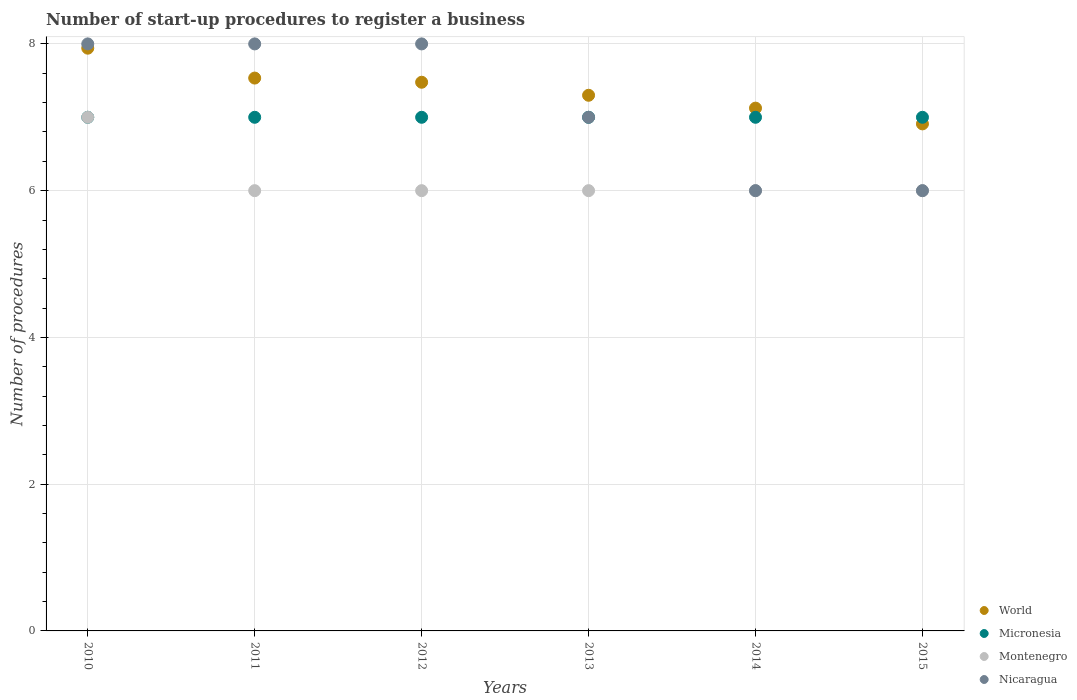How many different coloured dotlines are there?
Make the answer very short. 4. Is the number of dotlines equal to the number of legend labels?
Your response must be concise. Yes. What is the number of procedures required to register a business in Montenegro in 2012?
Offer a very short reply. 6. Across all years, what is the maximum number of procedures required to register a business in Montenegro?
Offer a very short reply. 7. Across all years, what is the minimum number of procedures required to register a business in Micronesia?
Ensure brevity in your answer.  7. In which year was the number of procedures required to register a business in World maximum?
Your answer should be very brief. 2010. In which year was the number of procedures required to register a business in Montenegro minimum?
Your response must be concise. 2011. What is the total number of procedures required to register a business in Micronesia in the graph?
Offer a very short reply. 42. What is the difference between the number of procedures required to register a business in World in 2014 and that in 2015?
Your answer should be very brief. 0.21. What is the difference between the number of procedures required to register a business in Nicaragua in 2014 and the number of procedures required to register a business in Micronesia in 2012?
Provide a short and direct response. -1. What is the average number of procedures required to register a business in World per year?
Your answer should be compact. 7.38. In the year 2014, what is the difference between the number of procedures required to register a business in Montenegro and number of procedures required to register a business in Micronesia?
Your answer should be compact. -1. What is the ratio of the number of procedures required to register a business in Nicaragua in 2011 to that in 2012?
Give a very brief answer. 1. Is the number of procedures required to register a business in World in 2014 less than that in 2015?
Offer a terse response. No. What is the difference between the highest and the lowest number of procedures required to register a business in Nicaragua?
Provide a succinct answer. 2. Is it the case that in every year, the sum of the number of procedures required to register a business in Montenegro and number of procedures required to register a business in World  is greater than the sum of number of procedures required to register a business in Micronesia and number of procedures required to register a business in Nicaragua?
Provide a succinct answer. No. Is the number of procedures required to register a business in Micronesia strictly greater than the number of procedures required to register a business in Montenegro over the years?
Ensure brevity in your answer.  No. How many dotlines are there?
Provide a short and direct response. 4. How many legend labels are there?
Offer a very short reply. 4. What is the title of the graph?
Offer a very short reply. Number of start-up procedures to register a business. What is the label or title of the X-axis?
Your response must be concise. Years. What is the label or title of the Y-axis?
Your response must be concise. Number of procedures. What is the Number of procedures in World in 2010?
Offer a terse response. 7.94. What is the Number of procedures of Micronesia in 2010?
Ensure brevity in your answer.  7. What is the Number of procedures of Montenegro in 2010?
Offer a very short reply. 7. What is the Number of procedures in World in 2011?
Provide a short and direct response. 7.53. What is the Number of procedures of Micronesia in 2011?
Offer a terse response. 7. What is the Number of procedures of Montenegro in 2011?
Give a very brief answer. 6. What is the Number of procedures in World in 2012?
Offer a terse response. 7.48. What is the Number of procedures in Micronesia in 2012?
Offer a very short reply. 7. What is the Number of procedures of World in 2013?
Offer a terse response. 7.3. What is the Number of procedures of Micronesia in 2013?
Provide a succinct answer. 7. What is the Number of procedures in Montenegro in 2013?
Provide a succinct answer. 6. What is the Number of procedures of Nicaragua in 2013?
Make the answer very short. 7. What is the Number of procedures of World in 2014?
Provide a succinct answer. 7.12. What is the Number of procedures in Micronesia in 2014?
Your answer should be compact. 7. What is the Number of procedures in Montenegro in 2014?
Offer a terse response. 6. What is the Number of procedures of Nicaragua in 2014?
Your response must be concise. 6. What is the Number of procedures of World in 2015?
Offer a very short reply. 6.91. What is the Number of procedures in Montenegro in 2015?
Your answer should be compact. 6. Across all years, what is the maximum Number of procedures of World?
Offer a terse response. 7.94. Across all years, what is the maximum Number of procedures in Micronesia?
Ensure brevity in your answer.  7. Across all years, what is the maximum Number of procedures in Montenegro?
Keep it short and to the point. 7. Across all years, what is the minimum Number of procedures in World?
Your answer should be compact. 6.91. What is the total Number of procedures in World in the graph?
Make the answer very short. 44.29. What is the total Number of procedures of Micronesia in the graph?
Make the answer very short. 42. What is the total Number of procedures of Nicaragua in the graph?
Offer a terse response. 43. What is the difference between the Number of procedures in World in 2010 and that in 2011?
Make the answer very short. 0.41. What is the difference between the Number of procedures of World in 2010 and that in 2012?
Offer a terse response. 0.46. What is the difference between the Number of procedures in Micronesia in 2010 and that in 2012?
Ensure brevity in your answer.  0. What is the difference between the Number of procedures in Nicaragua in 2010 and that in 2012?
Offer a very short reply. 0. What is the difference between the Number of procedures of World in 2010 and that in 2013?
Give a very brief answer. 0.64. What is the difference between the Number of procedures of World in 2010 and that in 2014?
Keep it short and to the point. 0.82. What is the difference between the Number of procedures of Montenegro in 2010 and that in 2014?
Your answer should be compact. 1. What is the difference between the Number of procedures of Nicaragua in 2010 and that in 2014?
Offer a terse response. 2. What is the difference between the Number of procedures of World in 2010 and that in 2015?
Your answer should be compact. 1.03. What is the difference between the Number of procedures in World in 2011 and that in 2012?
Provide a short and direct response. 0.06. What is the difference between the Number of procedures of Micronesia in 2011 and that in 2012?
Offer a terse response. 0. What is the difference between the Number of procedures of Montenegro in 2011 and that in 2012?
Give a very brief answer. 0. What is the difference between the Number of procedures of World in 2011 and that in 2013?
Your answer should be very brief. 0.23. What is the difference between the Number of procedures in Nicaragua in 2011 and that in 2013?
Provide a short and direct response. 1. What is the difference between the Number of procedures of World in 2011 and that in 2014?
Offer a terse response. 0.41. What is the difference between the Number of procedures of Micronesia in 2011 and that in 2014?
Your answer should be compact. 0. What is the difference between the Number of procedures of Montenegro in 2011 and that in 2014?
Provide a succinct answer. 0. What is the difference between the Number of procedures of Nicaragua in 2011 and that in 2014?
Keep it short and to the point. 2. What is the difference between the Number of procedures in World in 2011 and that in 2015?
Make the answer very short. 0.62. What is the difference between the Number of procedures in Micronesia in 2011 and that in 2015?
Provide a succinct answer. 0. What is the difference between the Number of procedures in Nicaragua in 2011 and that in 2015?
Offer a very short reply. 2. What is the difference between the Number of procedures in World in 2012 and that in 2013?
Provide a succinct answer. 0.18. What is the difference between the Number of procedures in Micronesia in 2012 and that in 2013?
Provide a short and direct response. 0. What is the difference between the Number of procedures of Montenegro in 2012 and that in 2013?
Make the answer very short. 0. What is the difference between the Number of procedures in World in 2012 and that in 2014?
Ensure brevity in your answer.  0.35. What is the difference between the Number of procedures in Nicaragua in 2012 and that in 2014?
Give a very brief answer. 2. What is the difference between the Number of procedures in World in 2012 and that in 2015?
Provide a short and direct response. 0.57. What is the difference between the Number of procedures of World in 2013 and that in 2014?
Provide a succinct answer. 0.18. What is the difference between the Number of procedures in Micronesia in 2013 and that in 2014?
Your response must be concise. 0. What is the difference between the Number of procedures in Nicaragua in 2013 and that in 2014?
Provide a succinct answer. 1. What is the difference between the Number of procedures in World in 2013 and that in 2015?
Make the answer very short. 0.39. What is the difference between the Number of procedures of Nicaragua in 2013 and that in 2015?
Give a very brief answer. 1. What is the difference between the Number of procedures of World in 2014 and that in 2015?
Keep it short and to the point. 0.21. What is the difference between the Number of procedures in Micronesia in 2014 and that in 2015?
Provide a succinct answer. 0. What is the difference between the Number of procedures in Montenegro in 2014 and that in 2015?
Your response must be concise. 0. What is the difference between the Number of procedures in Nicaragua in 2014 and that in 2015?
Offer a terse response. 0. What is the difference between the Number of procedures in World in 2010 and the Number of procedures in Micronesia in 2011?
Ensure brevity in your answer.  0.94. What is the difference between the Number of procedures of World in 2010 and the Number of procedures of Montenegro in 2011?
Ensure brevity in your answer.  1.94. What is the difference between the Number of procedures in World in 2010 and the Number of procedures in Nicaragua in 2011?
Your answer should be compact. -0.06. What is the difference between the Number of procedures in Montenegro in 2010 and the Number of procedures in Nicaragua in 2011?
Give a very brief answer. -1. What is the difference between the Number of procedures in World in 2010 and the Number of procedures in Micronesia in 2012?
Your answer should be very brief. 0.94. What is the difference between the Number of procedures in World in 2010 and the Number of procedures in Montenegro in 2012?
Provide a succinct answer. 1.94. What is the difference between the Number of procedures of World in 2010 and the Number of procedures of Nicaragua in 2012?
Provide a short and direct response. -0.06. What is the difference between the Number of procedures in Micronesia in 2010 and the Number of procedures in Nicaragua in 2012?
Your answer should be compact. -1. What is the difference between the Number of procedures in World in 2010 and the Number of procedures in Micronesia in 2013?
Your response must be concise. 0.94. What is the difference between the Number of procedures in World in 2010 and the Number of procedures in Montenegro in 2013?
Provide a short and direct response. 1.94. What is the difference between the Number of procedures in World in 2010 and the Number of procedures in Nicaragua in 2013?
Provide a short and direct response. 0.94. What is the difference between the Number of procedures in World in 2010 and the Number of procedures in Micronesia in 2014?
Make the answer very short. 0.94. What is the difference between the Number of procedures in World in 2010 and the Number of procedures in Montenegro in 2014?
Provide a short and direct response. 1.94. What is the difference between the Number of procedures of World in 2010 and the Number of procedures of Nicaragua in 2014?
Offer a terse response. 1.94. What is the difference between the Number of procedures in Micronesia in 2010 and the Number of procedures in Montenegro in 2014?
Offer a terse response. 1. What is the difference between the Number of procedures in World in 2010 and the Number of procedures in Micronesia in 2015?
Your answer should be very brief. 0.94. What is the difference between the Number of procedures of World in 2010 and the Number of procedures of Montenegro in 2015?
Provide a short and direct response. 1.94. What is the difference between the Number of procedures of World in 2010 and the Number of procedures of Nicaragua in 2015?
Keep it short and to the point. 1.94. What is the difference between the Number of procedures in Micronesia in 2010 and the Number of procedures in Nicaragua in 2015?
Your answer should be compact. 1. What is the difference between the Number of procedures of World in 2011 and the Number of procedures of Micronesia in 2012?
Your response must be concise. 0.53. What is the difference between the Number of procedures in World in 2011 and the Number of procedures in Montenegro in 2012?
Keep it short and to the point. 1.53. What is the difference between the Number of procedures in World in 2011 and the Number of procedures in Nicaragua in 2012?
Ensure brevity in your answer.  -0.47. What is the difference between the Number of procedures of Micronesia in 2011 and the Number of procedures of Nicaragua in 2012?
Provide a short and direct response. -1. What is the difference between the Number of procedures in Montenegro in 2011 and the Number of procedures in Nicaragua in 2012?
Offer a very short reply. -2. What is the difference between the Number of procedures of World in 2011 and the Number of procedures of Micronesia in 2013?
Offer a terse response. 0.53. What is the difference between the Number of procedures in World in 2011 and the Number of procedures in Montenegro in 2013?
Offer a terse response. 1.53. What is the difference between the Number of procedures in World in 2011 and the Number of procedures in Nicaragua in 2013?
Give a very brief answer. 0.53. What is the difference between the Number of procedures of Micronesia in 2011 and the Number of procedures of Nicaragua in 2013?
Offer a very short reply. 0. What is the difference between the Number of procedures of World in 2011 and the Number of procedures of Micronesia in 2014?
Offer a terse response. 0.53. What is the difference between the Number of procedures in World in 2011 and the Number of procedures in Montenegro in 2014?
Keep it short and to the point. 1.53. What is the difference between the Number of procedures in World in 2011 and the Number of procedures in Nicaragua in 2014?
Keep it short and to the point. 1.53. What is the difference between the Number of procedures in Micronesia in 2011 and the Number of procedures in Nicaragua in 2014?
Give a very brief answer. 1. What is the difference between the Number of procedures in Montenegro in 2011 and the Number of procedures in Nicaragua in 2014?
Your response must be concise. 0. What is the difference between the Number of procedures of World in 2011 and the Number of procedures of Micronesia in 2015?
Make the answer very short. 0.53. What is the difference between the Number of procedures in World in 2011 and the Number of procedures in Montenegro in 2015?
Give a very brief answer. 1.53. What is the difference between the Number of procedures of World in 2011 and the Number of procedures of Nicaragua in 2015?
Keep it short and to the point. 1.53. What is the difference between the Number of procedures in Micronesia in 2011 and the Number of procedures in Nicaragua in 2015?
Offer a very short reply. 1. What is the difference between the Number of procedures of World in 2012 and the Number of procedures of Micronesia in 2013?
Give a very brief answer. 0.48. What is the difference between the Number of procedures in World in 2012 and the Number of procedures in Montenegro in 2013?
Offer a terse response. 1.48. What is the difference between the Number of procedures in World in 2012 and the Number of procedures in Nicaragua in 2013?
Provide a short and direct response. 0.48. What is the difference between the Number of procedures of Micronesia in 2012 and the Number of procedures of Montenegro in 2013?
Ensure brevity in your answer.  1. What is the difference between the Number of procedures of Micronesia in 2012 and the Number of procedures of Nicaragua in 2013?
Give a very brief answer. 0. What is the difference between the Number of procedures of Montenegro in 2012 and the Number of procedures of Nicaragua in 2013?
Keep it short and to the point. -1. What is the difference between the Number of procedures of World in 2012 and the Number of procedures of Micronesia in 2014?
Your answer should be compact. 0.48. What is the difference between the Number of procedures in World in 2012 and the Number of procedures in Montenegro in 2014?
Ensure brevity in your answer.  1.48. What is the difference between the Number of procedures in World in 2012 and the Number of procedures in Nicaragua in 2014?
Your answer should be very brief. 1.48. What is the difference between the Number of procedures in Micronesia in 2012 and the Number of procedures in Nicaragua in 2014?
Ensure brevity in your answer.  1. What is the difference between the Number of procedures of Montenegro in 2012 and the Number of procedures of Nicaragua in 2014?
Ensure brevity in your answer.  0. What is the difference between the Number of procedures of World in 2012 and the Number of procedures of Micronesia in 2015?
Your answer should be very brief. 0.48. What is the difference between the Number of procedures of World in 2012 and the Number of procedures of Montenegro in 2015?
Your response must be concise. 1.48. What is the difference between the Number of procedures in World in 2012 and the Number of procedures in Nicaragua in 2015?
Your response must be concise. 1.48. What is the difference between the Number of procedures in Micronesia in 2012 and the Number of procedures in Montenegro in 2015?
Provide a short and direct response. 1. What is the difference between the Number of procedures of Micronesia in 2012 and the Number of procedures of Nicaragua in 2015?
Give a very brief answer. 1. What is the difference between the Number of procedures of World in 2013 and the Number of procedures of Nicaragua in 2014?
Offer a very short reply. 1.3. What is the difference between the Number of procedures in Micronesia in 2013 and the Number of procedures in Nicaragua in 2014?
Offer a very short reply. 1. What is the difference between the Number of procedures in Montenegro in 2013 and the Number of procedures in Nicaragua in 2014?
Your answer should be very brief. 0. What is the difference between the Number of procedures of Micronesia in 2013 and the Number of procedures of Nicaragua in 2015?
Your answer should be very brief. 1. What is the difference between the Number of procedures of Montenegro in 2013 and the Number of procedures of Nicaragua in 2015?
Your response must be concise. 0. What is the difference between the Number of procedures in World in 2014 and the Number of procedures in Micronesia in 2015?
Make the answer very short. 0.12. What is the difference between the Number of procedures of World in 2014 and the Number of procedures of Montenegro in 2015?
Provide a short and direct response. 1.12. What is the difference between the Number of procedures of World in 2014 and the Number of procedures of Nicaragua in 2015?
Your answer should be very brief. 1.12. What is the difference between the Number of procedures in Micronesia in 2014 and the Number of procedures in Nicaragua in 2015?
Offer a terse response. 1. What is the average Number of procedures in World per year?
Keep it short and to the point. 7.38. What is the average Number of procedures of Montenegro per year?
Offer a very short reply. 6.17. What is the average Number of procedures in Nicaragua per year?
Your response must be concise. 7.17. In the year 2010, what is the difference between the Number of procedures in World and Number of procedures in Micronesia?
Offer a very short reply. 0.94. In the year 2010, what is the difference between the Number of procedures in World and Number of procedures in Montenegro?
Ensure brevity in your answer.  0.94. In the year 2010, what is the difference between the Number of procedures in World and Number of procedures in Nicaragua?
Give a very brief answer. -0.06. In the year 2010, what is the difference between the Number of procedures in Micronesia and Number of procedures in Montenegro?
Offer a terse response. 0. In the year 2010, what is the difference between the Number of procedures of Micronesia and Number of procedures of Nicaragua?
Ensure brevity in your answer.  -1. In the year 2011, what is the difference between the Number of procedures in World and Number of procedures in Micronesia?
Give a very brief answer. 0.53. In the year 2011, what is the difference between the Number of procedures of World and Number of procedures of Montenegro?
Give a very brief answer. 1.53. In the year 2011, what is the difference between the Number of procedures of World and Number of procedures of Nicaragua?
Make the answer very short. -0.47. In the year 2011, what is the difference between the Number of procedures in Micronesia and Number of procedures in Montenegro?
Your answer should be very brief. 1. In the year 2012, what is the difference between the Number of procedures in World and Number of procedures in Micronesia?
Provide a succinct answer. 0.48. In the year 2012, what is the difference between the Number of procedures of World and Number of procedures of Montenegro?
Your answer should be compact. 1.48. In the year 2012, what is the difference between the Number of procedures of World and Number of procedures of Nicaragua?
Your answer should be compact. -0.52. In the year 2012, what is the difference between the Number of procedures of Micronesia and Number of procedures of Montenegro?
Provide a short and direct response. 1. In the year 2013, what is the difference between the Number of procedures of World and Number of procedures of Montenegro?
Give a very brief answer. 1.3. In the year 2013, what is the difference between the Number of procedures of World and Number of procedures of Nicaragua?
Offer a very short reply. 0.3. In the year 2013, what is the difference between the Number of procedures of Micronesia and Number of procedures of Montenegro?
Provide a succinct answer. 1. In the year 2013, what is the difference between the Number of procedures in Micronesia and Number of procedures in Nicaragua?
Offer a very short reply. 0. In the year 2013, what is the difference between the Number of procedures of Montenegro and Number of procedures of Nicaragua?
Your answer should be compact. -1. In the year 2014, what is the difference between the Number of procedures in World and Number of procedures in Micronesia?
Give a very brief answer. 0.12. In the year 2014, what is the difference between the Number of procedures in World and Number of procedures in Montenegro?
Offer a terse response. 1.12. In the year 2014, what is the difference between the Number of procedures of World and Number of procedures of Nicaragua?
Your answer should be very brief. 1.12. In the year 2014, what is the difference between the Number of procedures of Micronesia and Number of procedures of Nicaragua?
Offer a terse response. 1. In the year 2015, what is the difference between the Number of procedures of World and Number of procedures of Micronesia?
Provide a short and direct response. -0.09. In the year 2015, what is the difference between the Number of procedures in World and Number of procedures in Montenegro?
Offer a terse response. 0.91. In the year 2015, what is the difference between the Number of procedures in World and Number of procedures in Nicaragua?
Your answer should be compact. 0.91. In the year 2015, what is the difference between the Number of procedures in Montenegro and Number of procedures in Nicaragua?
Your answer should be compact. 0. What is the ratio of the Number of procedures in World in 2010 to that in 2011?
Offer a terse response. 1.05. What is the ratio of the Number of procedures in Montenegro in 2010 to that in 2011?
Keep it short and to the point. 1.17. What is the ratio of the Number of procedures of World in 2010 to that in 2012?
Your answer should be very brief. 1.06. What is the ratio of the Number of procedures of Micronesia in 2010 to that in 2012?
Your answer should be compact. 1. What is the ratio of the Number of procedures of Nicaragua in 2010 to that in 2012?
Provide a succinct answer. 1. What is the ratio of the Number of procedures of World in 2010 to that in 2013?
Offer a very short reply. 1.09. What is the ratio of the Number of procedures in Micronesia in 2010 to that in 2013?
Offer a terse response. 1. What is the ratio of the Number of procedures in Nicaragua in 2010 to that in 2013?
Make the answer very short. 1.14. What is the ratio of the Number of procedures of World in 2010 to that in 2014?
Give a very brief answer. 1.11. What is the ratio of the Number of procedures in World in 2010 to that in 2015?
Make the answer very short. 1.15. What is the ratio of the Number of procedures of Micronesia in 2010 to that in 2015?
Ensure brevity in your answer.  1. What is the ratio of the Number of procedures in World in 2011 to that in 2012?
Offer a terse response. 1.01. What is the ratio of the Number of procedures in Montenegro in 2011 to that in 2012?
Provide a short and direct response. 1. What is the ratio of the Number of procedures of Nicaragua in 2011 to that in 2012?
Your response must be concise. 1. What is the ratio of the Number of procedures in World in 2011 to that in 2013?
Ensure brevity in your answer.  1.03. What is the ratio of the Number of procedures in Micronesia in 2011 to that in 2013?
Your answer should be very brief. 1. What is the ratio of the Number of procedures of World in 2011 to that in 2014?
Your answer should be compact. 1.06. What is the ratio of the Number of procedures in Montenegro in 2011 to that in 2014?
Ensure brevity in your answer.  1. What is the ratio of the Number of procedures in Nicaragua in 2011 to that in 2014?
Offer a very short reply. 1.33. What is the ratio of the Number of procedures in World in 2011 to that in 2015?
Your response must be concise. 1.09. What is the ratio of the Number of procedures in Montenegro in 2011 to that in 2015?
Provide a short and direct response. 1. What is the ratio of the Number of procedures in World in 2012 to that in 2013?
Offer a terse response. 1.02. What is the ratio of the Number of procedures of Micronesia in 2012 to that in 2013?
Your answer should be very brief. 1. What is the ratio of the Number of procedures of Nicaragua in 2012 to that in 2013?
Provide a short and direct response. 1.14. What is the ratio of the Number of procedures of World in 2012 to that in 2014?
Offer a terse response. 1.05. What is the ratio of the Number of procedures in Micronesia in 2012 to that in 2014?
Provide a succinct answer. 1. What is the ratio of the Number of procedures of Nicaragua in 2012 to that in 2014?
Make the answer very short. 1.33. What is the ratio of the Number of procedures of World in 2012 to that in 2015?
Make the answer very short. 1.08. What is the ratio of the Number of procedures in Montenegro in 2012 to that in 2015?
Offer a terse response. 1. What is the ratio of the Number of procedures of World in 2013 to that in 2014?
Give a very brief answer. 1.02. What is the ratio of the Number of procedures of Micronesia in 2013 to that in 2014?
Offer a very short reply. 1. What is the ratio of the Number of procedures of Nicaragua in 2013 to that in 2014?
Provide a succinct answer. 1.17. What is the ratio of the Number of procedures of World in 2013 to that in 2015?
Your answer should be very brief. 1.06. What is the ratio of the Number of procedures of World in 2014 to that in 2015?
Offer a terse response. 1.03. What is the ratio of the Number of procedures in Micronesia in 2014 to that in 2015?
Ensure brevity in your answer.  1. What is the difference between the highest and the second highest Number of procedures of World?
Give a very brief answer. 0.41. What is the difference between the highest and the second highest Number of procedures of Montenegro?
Your answer should be very brief. 1. What is the difference between the highest and the second highest Number of procedures in Nicaragua?
Give a very brief answer. 0. What is the difference between the highest and the lowest Number of procedures of World?
Your answer should be compact. 1.03. What is the difference between the highest and the lowest Number of procedures of Micronesia?
Keep it short and to the point. 0. What is the difference between the highest and the lowest Number of procedures in Montenegro?
Offer a very short reply. 1. 